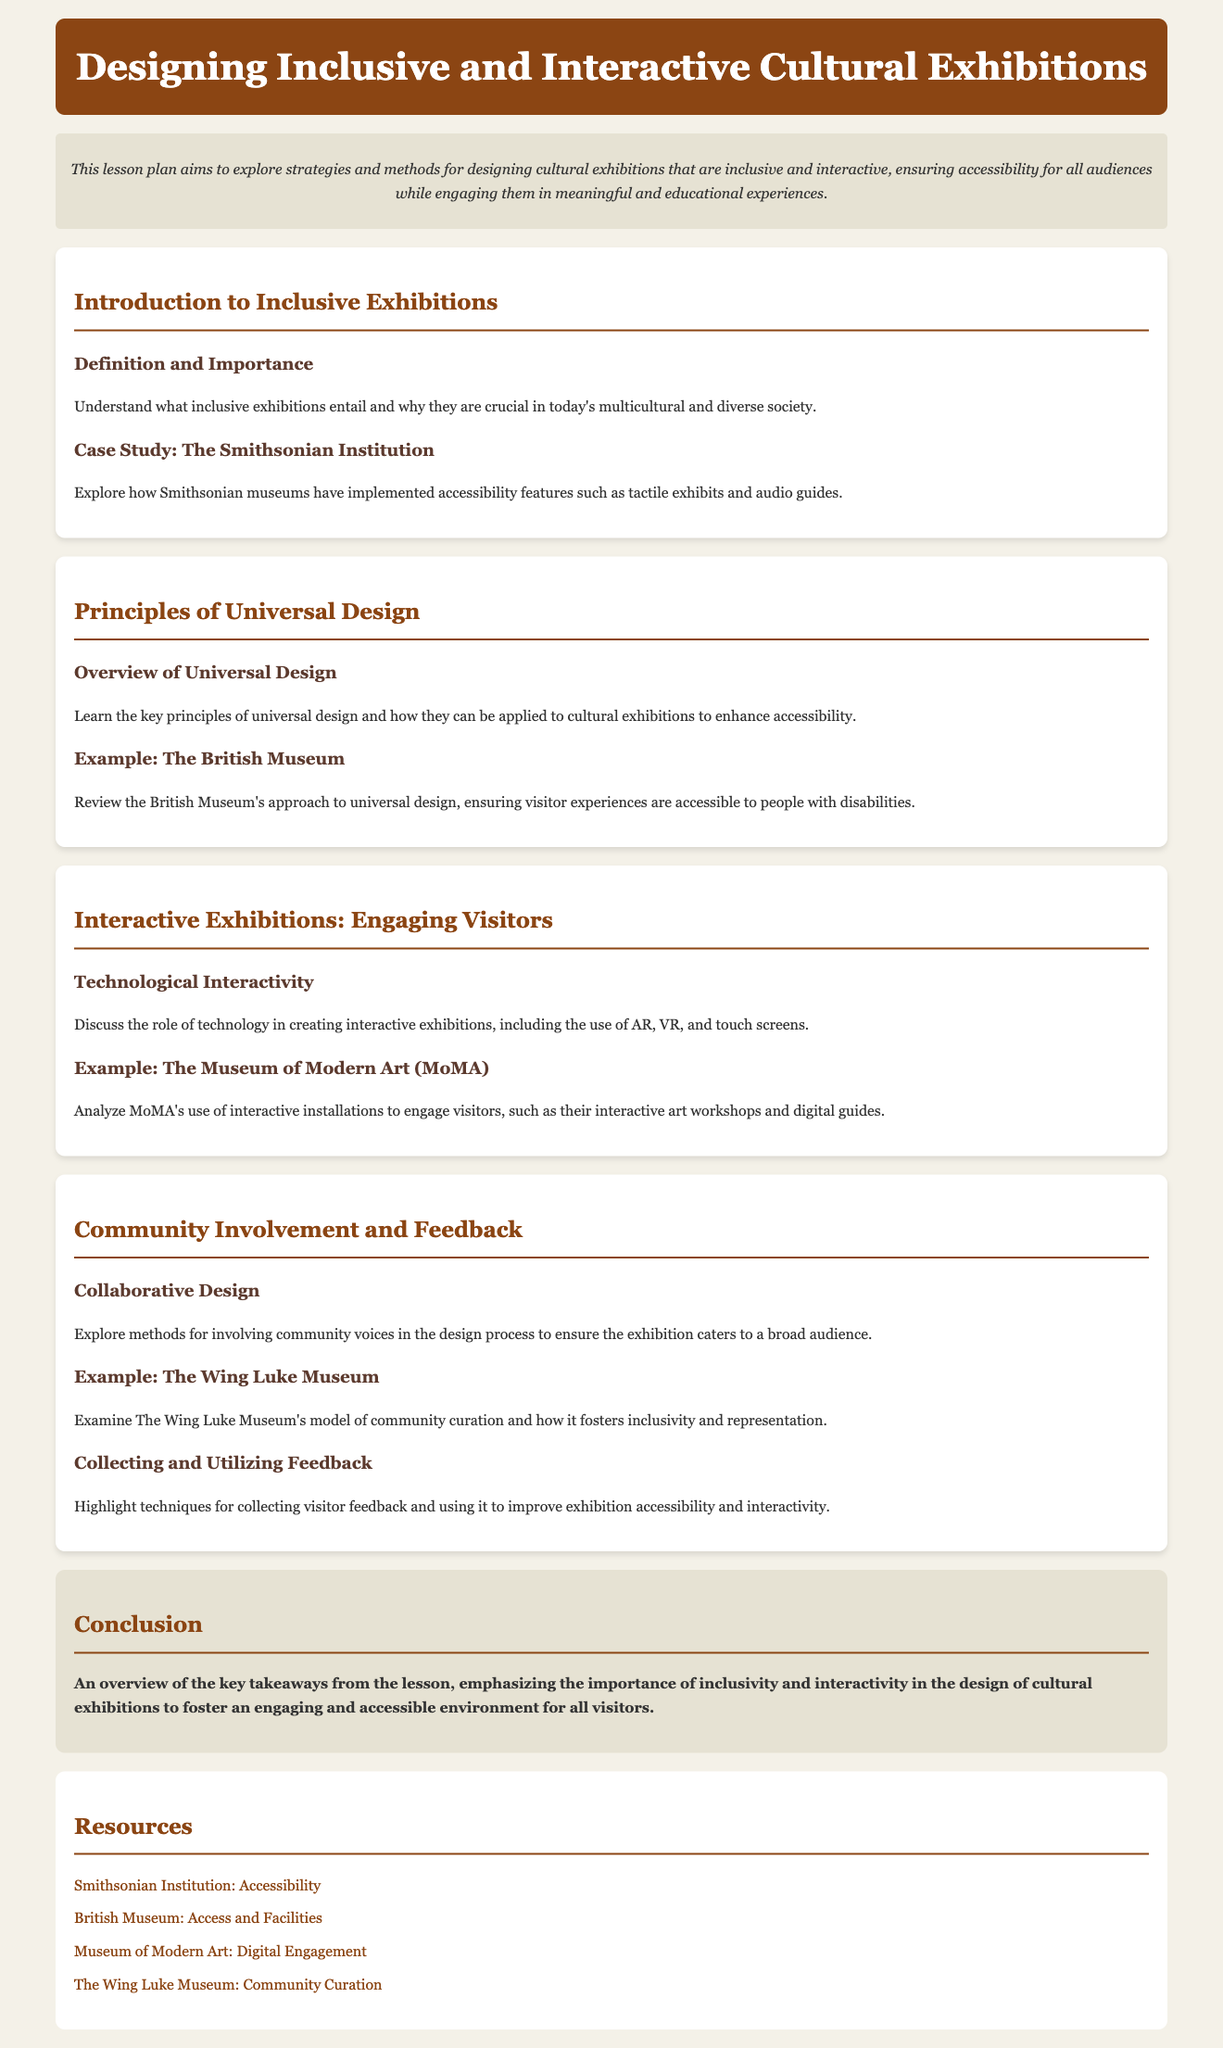what is the title of the lesson plan? The title of the lesson plan is found in the header section of the document.
Answer: Designing Inclusive and Interactive Cultural Exhibitions what organization is examined in the case study for accessibility features? The case study mentioned discusses a specific institution known for accessibility features in exhibitions.
Answer: Smithsonian Institution what approach does the British Museum take regarding visitor accessibility? The document states the British Museum's approach to universal design is in line with enhancing visitor experiences.
Answer: Universal design which technology is discussed for creating interactive exhibitions? The role of technology is highlighted for its importance in exhibitions, including specific types of technology mentioned.
Answer: AR, VR, and touch screens what is the model used by The Wing Luke Museum? The document elaborates on a particular model that the museum employs to ensure inclusivity and representation.
Answer: Community curation what is one method suggested for collecting visitor feedback? The document outlines techniques related to visitor feedback incorporated in the lesson on exhibitions.
Answer: Collecting feedback what is emphasized as a key takeaway in the conclusion? The conclusion summarizes the main focus of the lesson plan regarding exhibition design.
Answer: Inclusivity and interactivity 